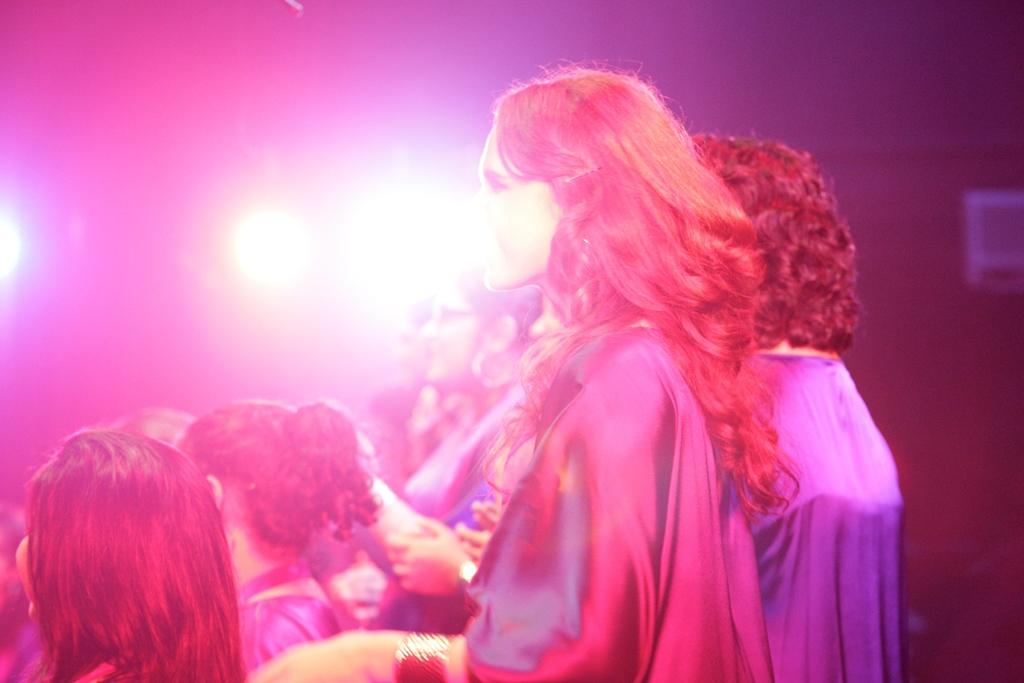How many people are in the image? There is a group of people in the image, but the exact number cannot be determined from the provided facts. What can be seen in the background of the image? There are lights visible in the background of the image. What type of education is being taught in the winter season in the image? There is no reference to education or winter in the image, so it is not possible to answer that question. 